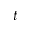Convert formula to latex. <formula><loc_0><loc_0><loc_500><loc_500>t</formula> 